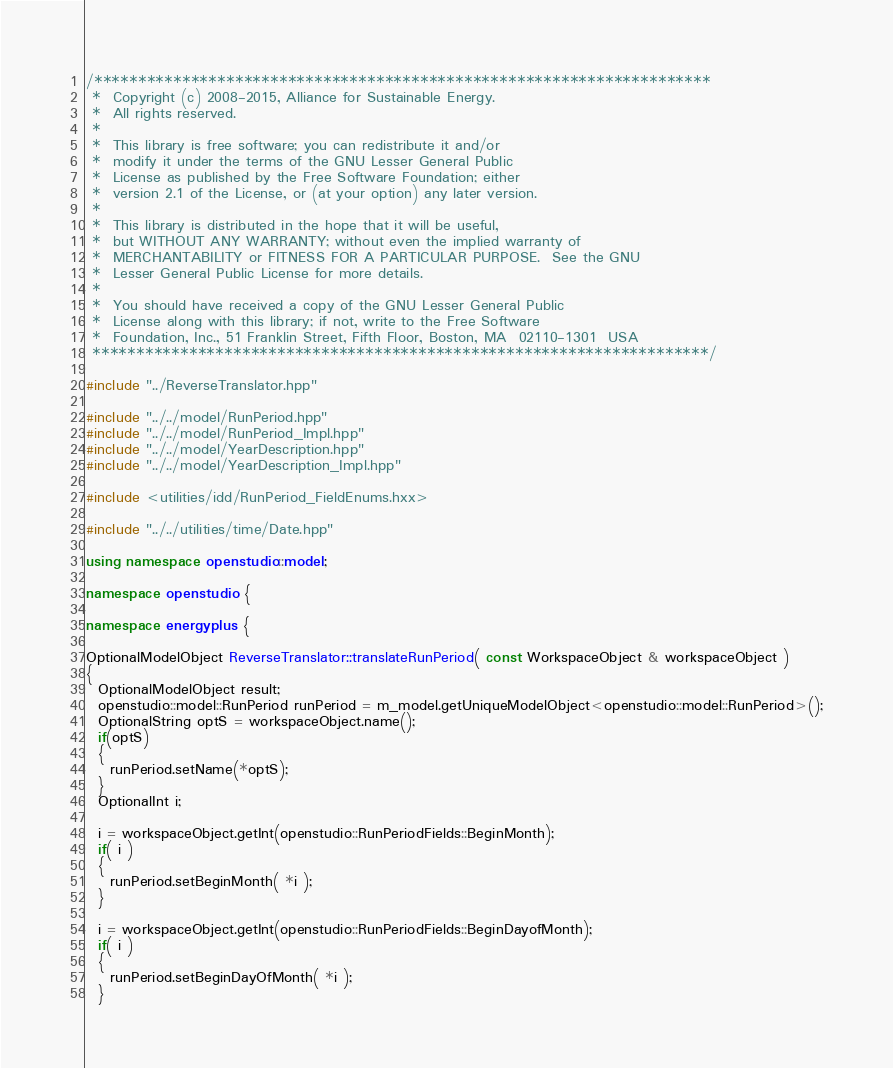Convert code to text. <code><loc_0><loc_0><loc_500><loc_500><_C++_>/**********************************************************************
 *  Copyright (c) 2008-2015, Alliance for Sustainable Energy.
 *  All rights reserved.
 *
 *  This library is free software; you can redistribute it and/or
 *  modify it under the terms of the GNU Lesser General Public
 *  License as published by the Free Software Foundation; either
 *  version 2.1 of the License, or (at your option) any later version.
 *
 *  This library is distributed in the hope that it will be useful,
 *  but WITHOUT ANY WARRANTY; without even the implied warranty of
 *  MERCHANTABILITY or FITNESS FOR A PARTICULAR PURPOSE.  See the GNU
 *  Lesser General Public License for more details.
 *
 *  You should have received a copy of the GNU Lesser General Public
 *  License along with this library; if not, write to the Free Software
 *  Foundation, Inc., 51 Franklin Street, Fifth Floor, Boston, MA  02110-1301  USA
 **********************************************************************/

#include "../ReverseTranslator.hpp"

#include "../../model/RunPeriod.hpp"
#include "../../model/RunPeriod_Impl.hpp"
#include "../../model/YearDescription.hpp"
#include "../../model/YearDescription_Impl.hpp"

#include <utilities/idd/RunPeriod_FieldEnums.hxx>

#include "../../utilities/time/Date.hpp"

using namespace openstudio::model;

namespace openstudio {

namespace energyplus {

OptionalModelObject ReverseTranslator::translateRunPeriod( const WorkspaceObject & workspaceObject )
{
  OptionalModelObject result;
  openstudio::model::RunPeriod runPeriod = m_model.getUniqueModelObject<openstudio::model::RunPeriod>();
  OptionalString optS = workspaceObject.name();
  if(optS)
  {
    runPeriod.setName(*optS);
  }
  OptionalInt i;

  i = workspaceObject.getInt(openstudio::RunPeriodFields::BeginMonth);
  if( i )
  {
    runPeriod.setBeginMonth( *i );
  }

  i = workspaceObject.getInt(openstudio::RunPeriodFields::BeginDayofMonth);
  if( i )
  {
    runPeriod.setBeginDayOfMonth( *i );
  }
</code> 